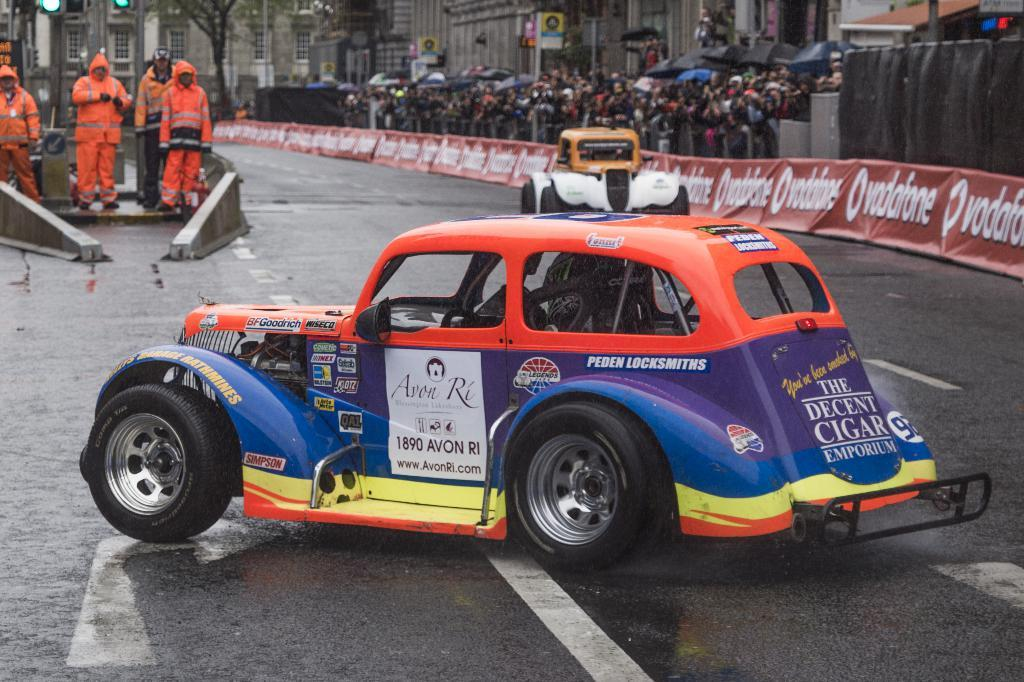How many cars can be seen on the road in the image? There are two cars on the road in the image. What else is present in the image besides the cars? There are people standing in the image, as well as a tree and buildings. What noise can be heard coming from the tree in the image? There is no noise coming from the tree in the image, as trees do not produce sounds. 